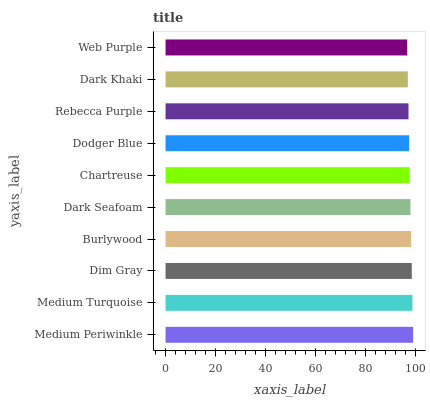Is Web Purple the minimum?
Answer yes or no. Yes. Is Medium Periwinkle the maximum?
Answer yes or no. Yes. Is Medium Turquoise the minimum?
Answer yes or no. No. Is Medium Turquoise the maximum?
Answer yes or no. No. Is Medium Periwinkle greater than Medium Turquoise?
Answer yes or no. Yes. Is Medium Turquoise less than Medium Periwinkle?
Answer yes or no. Yes. Is Medium Turquoise greater than Medium Periwinkle?
Answer yes or no. No. Is Medium Periwinkle less than Medium Turquoise?
Answer yes or no. No. Is Dark Seafoam the high median?
Answer yes or no. Yes. Is Chartreuse the low median?
Answer yes or no. Yes. Is Dark Khaki the high median?
Answer yes or no. No. Is Medium Periwinkle the low median?
Answer yes or no. No. 